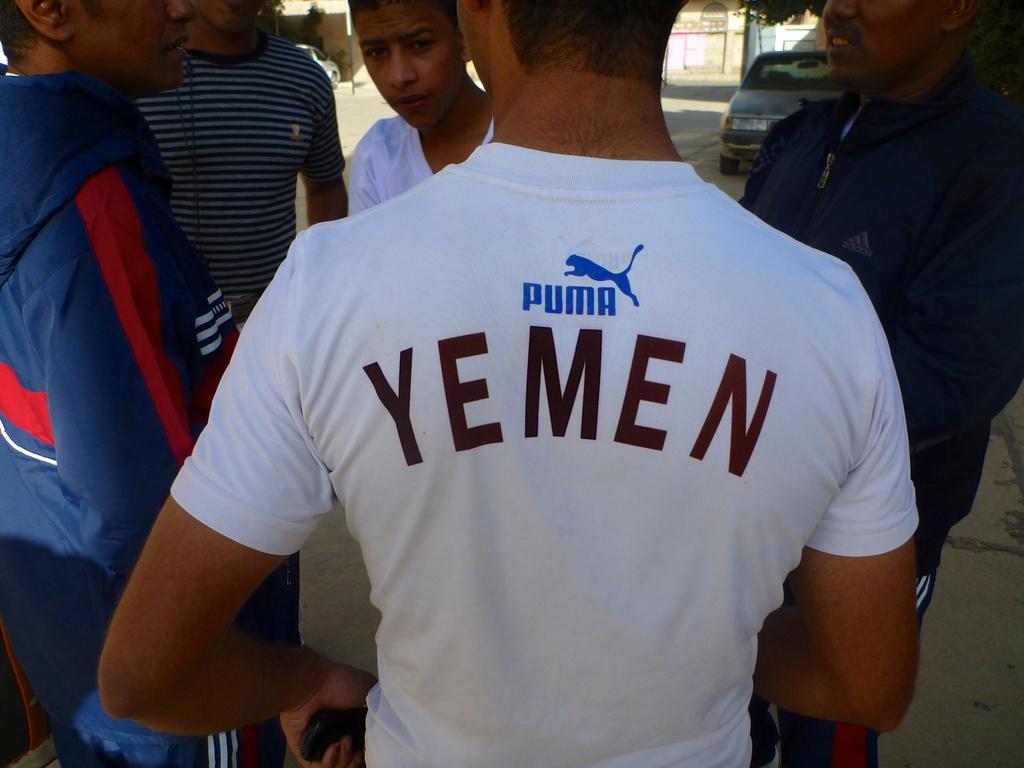What country is the gentleman in the white puma shirt supporting?
Ensure brevity in your answer.  Yemen. What is the brand of the shirt?
Make the answer very short. Puma. 